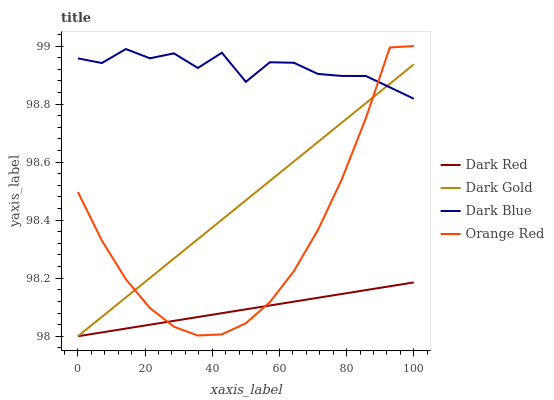Does Dark Red have the minimum area under the curve?
Answer yes or no. Yes. Does Dark Blue have the maximum area under the curve?
Answer yes or no. Yes. Does Orange Red have the minimum area under the curve?
Answer yes or no. No. Does Orange Red have the maximum area under the curve?
Answer yes or no. No. Is Dark Gold the smoothest?
Answer yes or no. Yes. Is Dark Blue the roughest?
Answer yes or no. Yes. Is Orange Red the smoothest?
Answer yes or no. No. Is Orange Red the roughest?
Answer yes or no. No. Does Dark Red have the lowest value?
Answer yes or no. Yes. Does Orange Red have the lowest value?
Answer yes or no. No. Does Orange Red have the highest value?
Answer yes or no. Yes. Does Dark Blue have the highest value?
Answer yes or no. No. Is Dark Red less than Dark Blue?
Answer yes or no. Yes. Is Dark Blue greater than Dark Red?
Answer yes or no. Yes. Does Dark Blue intersect Orange Red?
Answer yes or no. Yes. Is Dark Blue less than Orange Red?
Answer yes or no. No. Is Dark Blue greater than Orange Red?
Answer yes or no. No. Does Dark Red intersect Dark Blue?
Answer yes or no. No. 